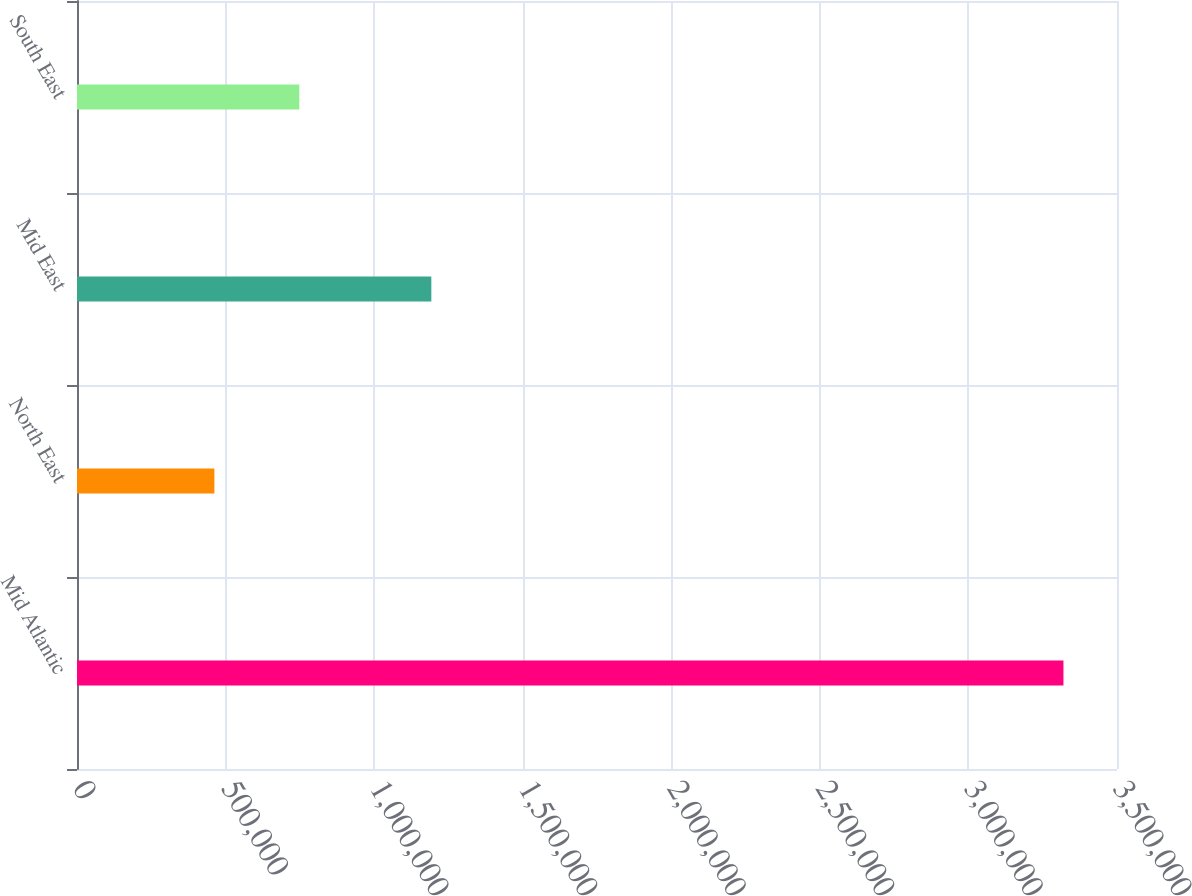Convert chart to OTSL. <chart><loc_0><loc_0><loc_500><loc_500><bar_chart><fcel>Mid Atlantic<fcel>North East<fcel>Mid East<fcel>South East<nl><fcel>3.31978e+06<fcel>462385<fcel>1.19247e+06<fcel>748124<nl></chart> 